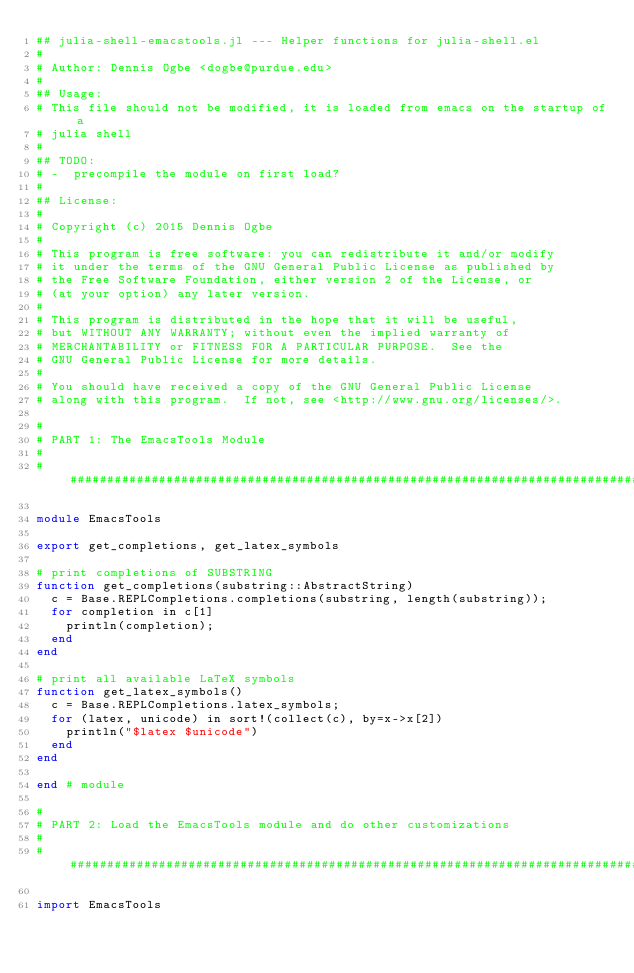<code> <loc_0><loc_0><loc_500><loc_500><_Julia_>## julia-shell-emacstools.jl --- Helper functions for julia-shell.el
#
# Author: Dennis Ogbe <dogbe@purdue.edu>
#
## Usage:
# This file should not be modified, it is loaded from emacs on the startup of a
# julia shell
#
## TODO:
# -  precompile the module on first load?
#
## License:
#
# Copyright (c) 2015 Dennis Ogbe
#
# This program is free software: you can redistribute it and/or modify
# it under the terms of the GNU General Public License as published by
# the Free Software Foundation, either version 2 of the License, or
# (at your option) any later version.
#
# This program is distributed in the hope that it will be useful,
# but WITHOUT ANY WARRANTY; without even the implied warranty of
# MERCHANTABILITY or FITNESS FOR A PARTICULAR PURPOSE.  See the
# GNU General Public License for more details.
#
# You should have received a copy of the GNU General Public License
# along with this program.  If not, see <http://www.gnu.org/licenses/>.

#
# PART 1: The EmacsTools Module
#
###############################################################################

module EmacsTools

export get_completions, get_latex_symbols

# print completions of SUBSTRING
function get_completions(substring::AbstractString)
  c = Base.REPLCompletions.completions(substring, length(substring));
  for completion in c[1]
    println(completion);
  end
end

# print all available LaTeX symbols
function get_latex_symbols()
  c = Base.REPLCompletions.latex_symbols;
  for (latex, unicode) in sort!(collect(c), by=x->x[2])
    println("$latex $unicode")
  end
end

end # module

#
# PART 2: Load the EmacsTools module and do other customizations
#
###############################################################################

import EmacsTools
</code> 